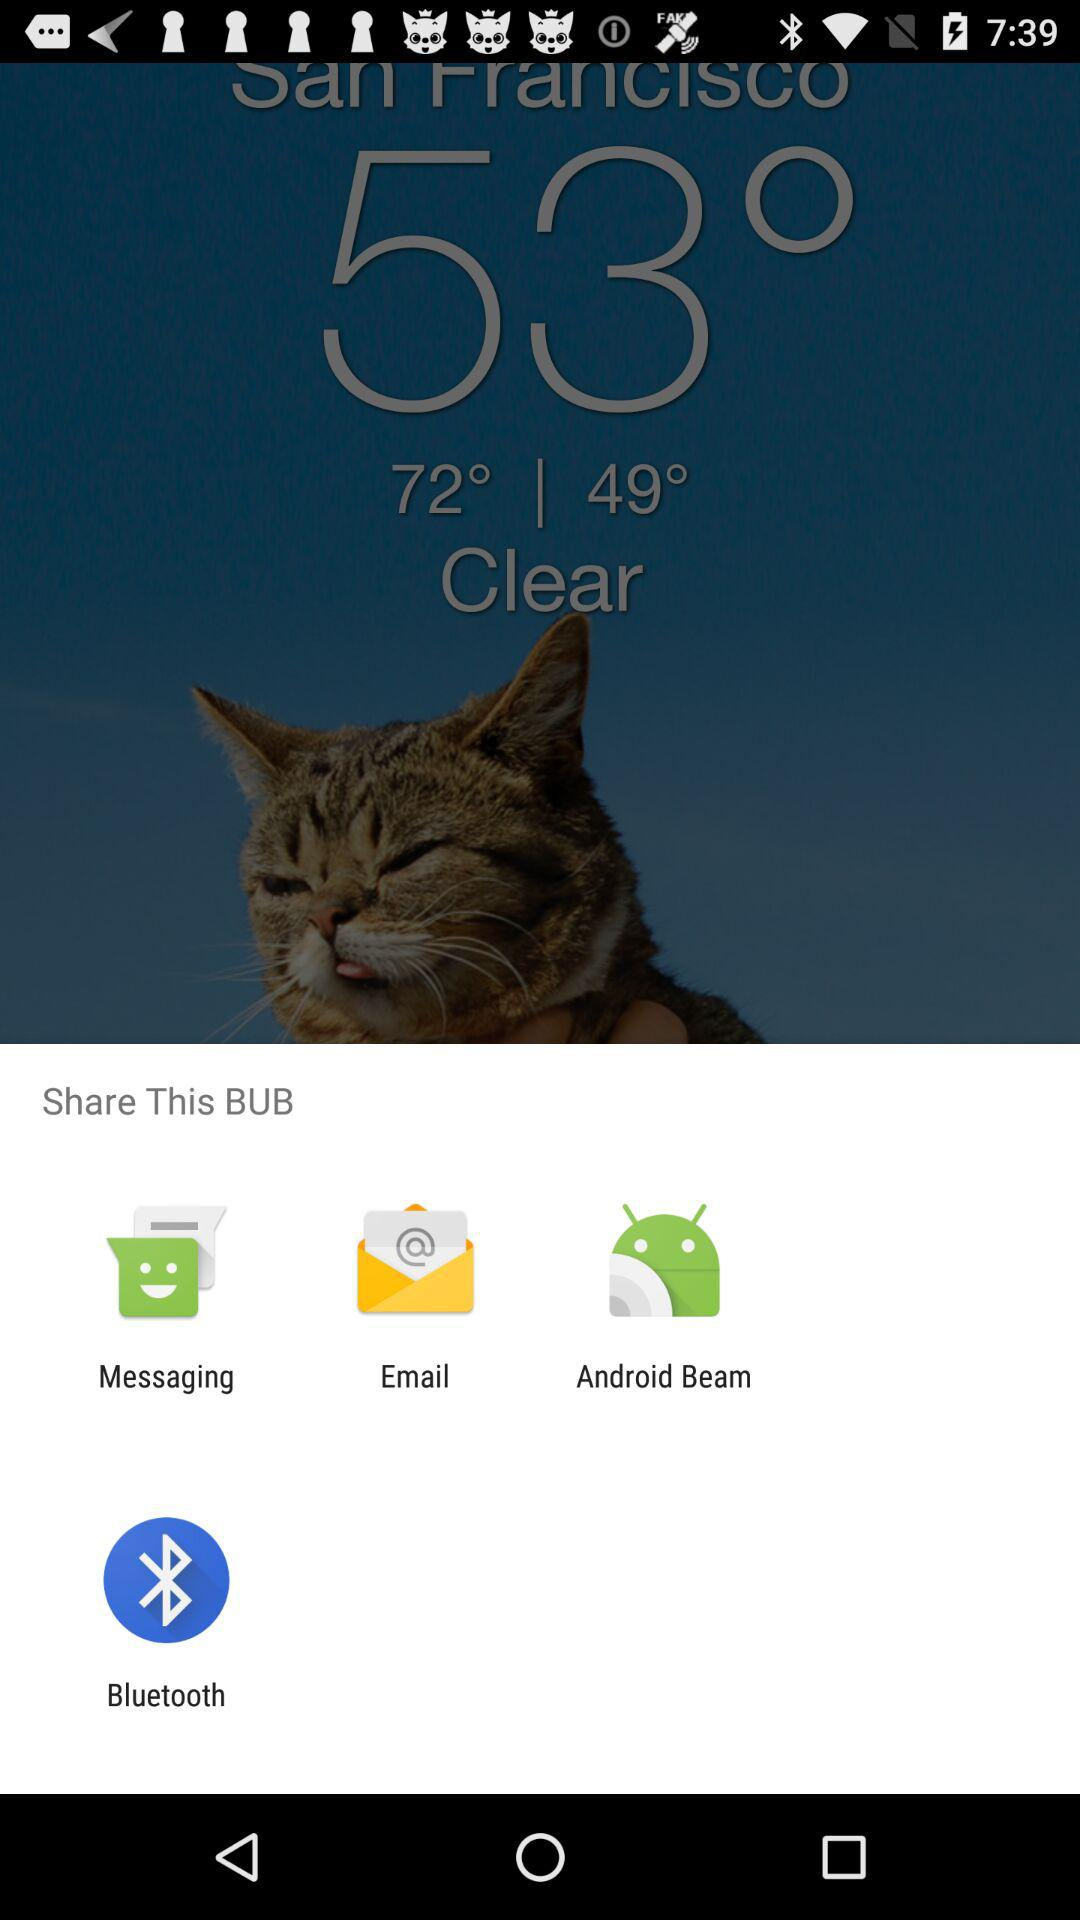What are the applications that can be used to share content? The applications are "Messaging", "Email", "Android Beam" and "Bluetooth". 